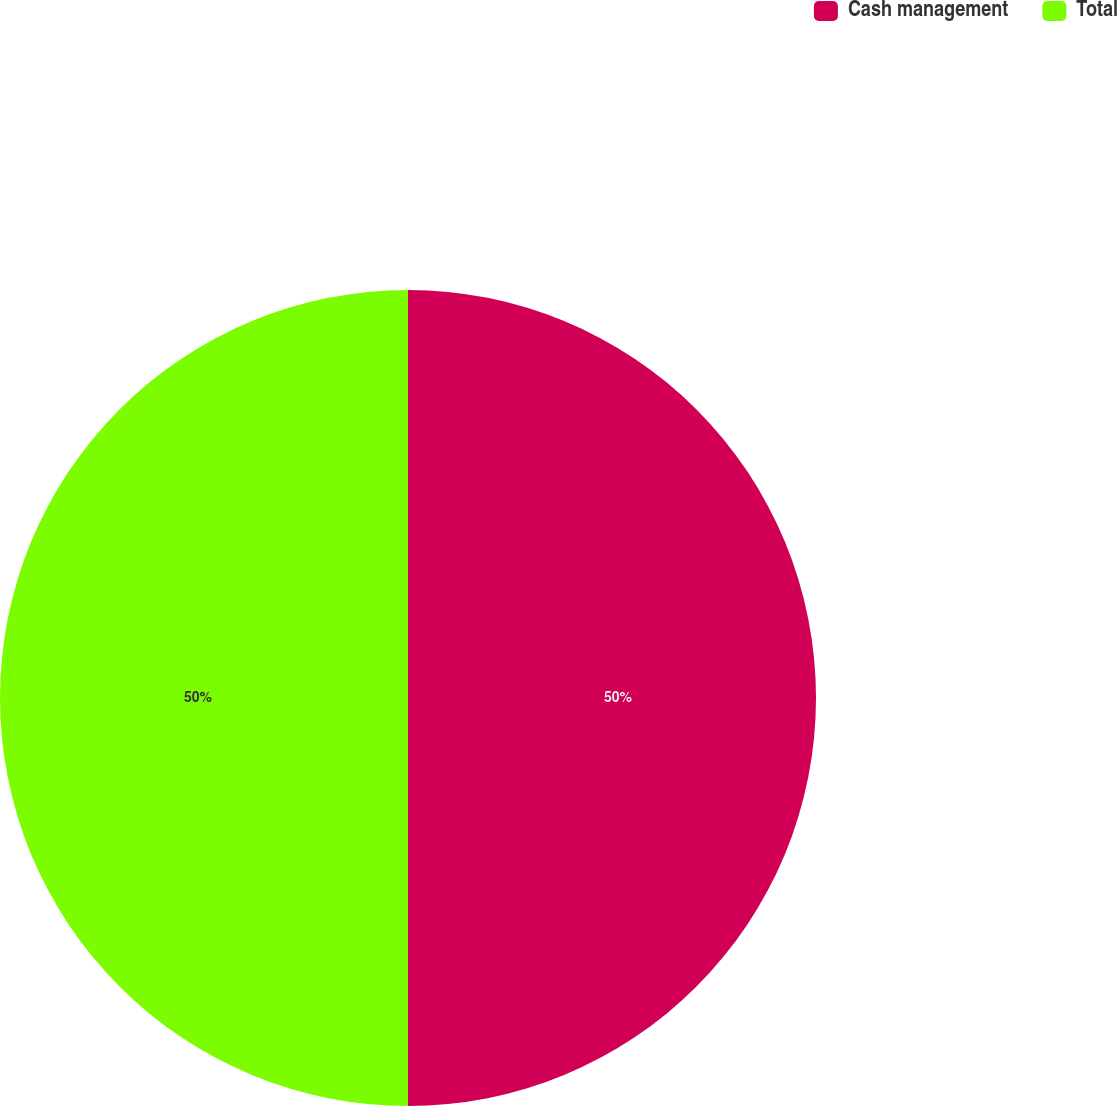Convert chart to OTSL. <chart><loc_0><loc_0><loc_500><loc_500><pie_chart><fcel>Cash management<fcel>Total<nl><fcel>50.0%<fcel>50.0%<nl></chart> 